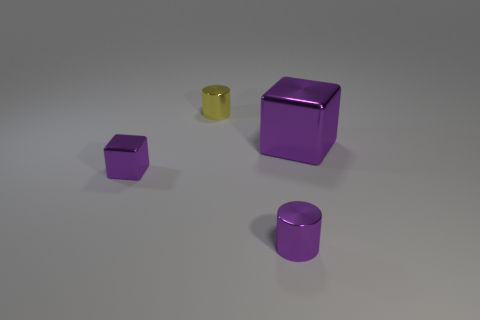Add 1 big purple metallic things. How many objects exist? 5 Subtract all large cubes. Subtract all tiny purple blocks. How many objects are left? 2 Add 4 metal objects. How many metal objects are left? 8 Add 1 tiny things. How many tiny things exist? 4 Subtract 0 brown balls. How many objects are left? 4 